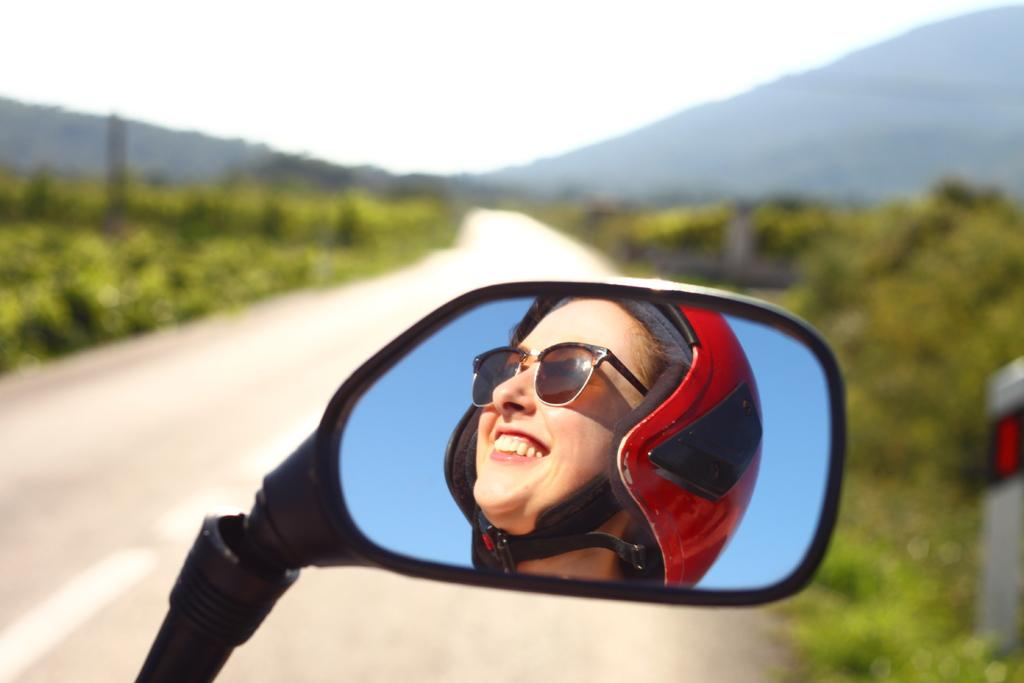What is the person in the image wearing on their head? The person is wearing a helmet in the image. What type of eyewear is the person wearing? The person is wearing sunglasses in the image. How can the person be seen in the image? The person is reflected in a mirror in the image. What can be seen in the background of the image? The background of the image includes the sky, green leaves, the ground, and other objects. What type of lace is draped over the person's shoulder in the image? There is no lace present in the image. What property does the person own in the image? There is no information about the person's property in the image. Is there a trampoline visible in the image? There is no trampoline present in the image. 